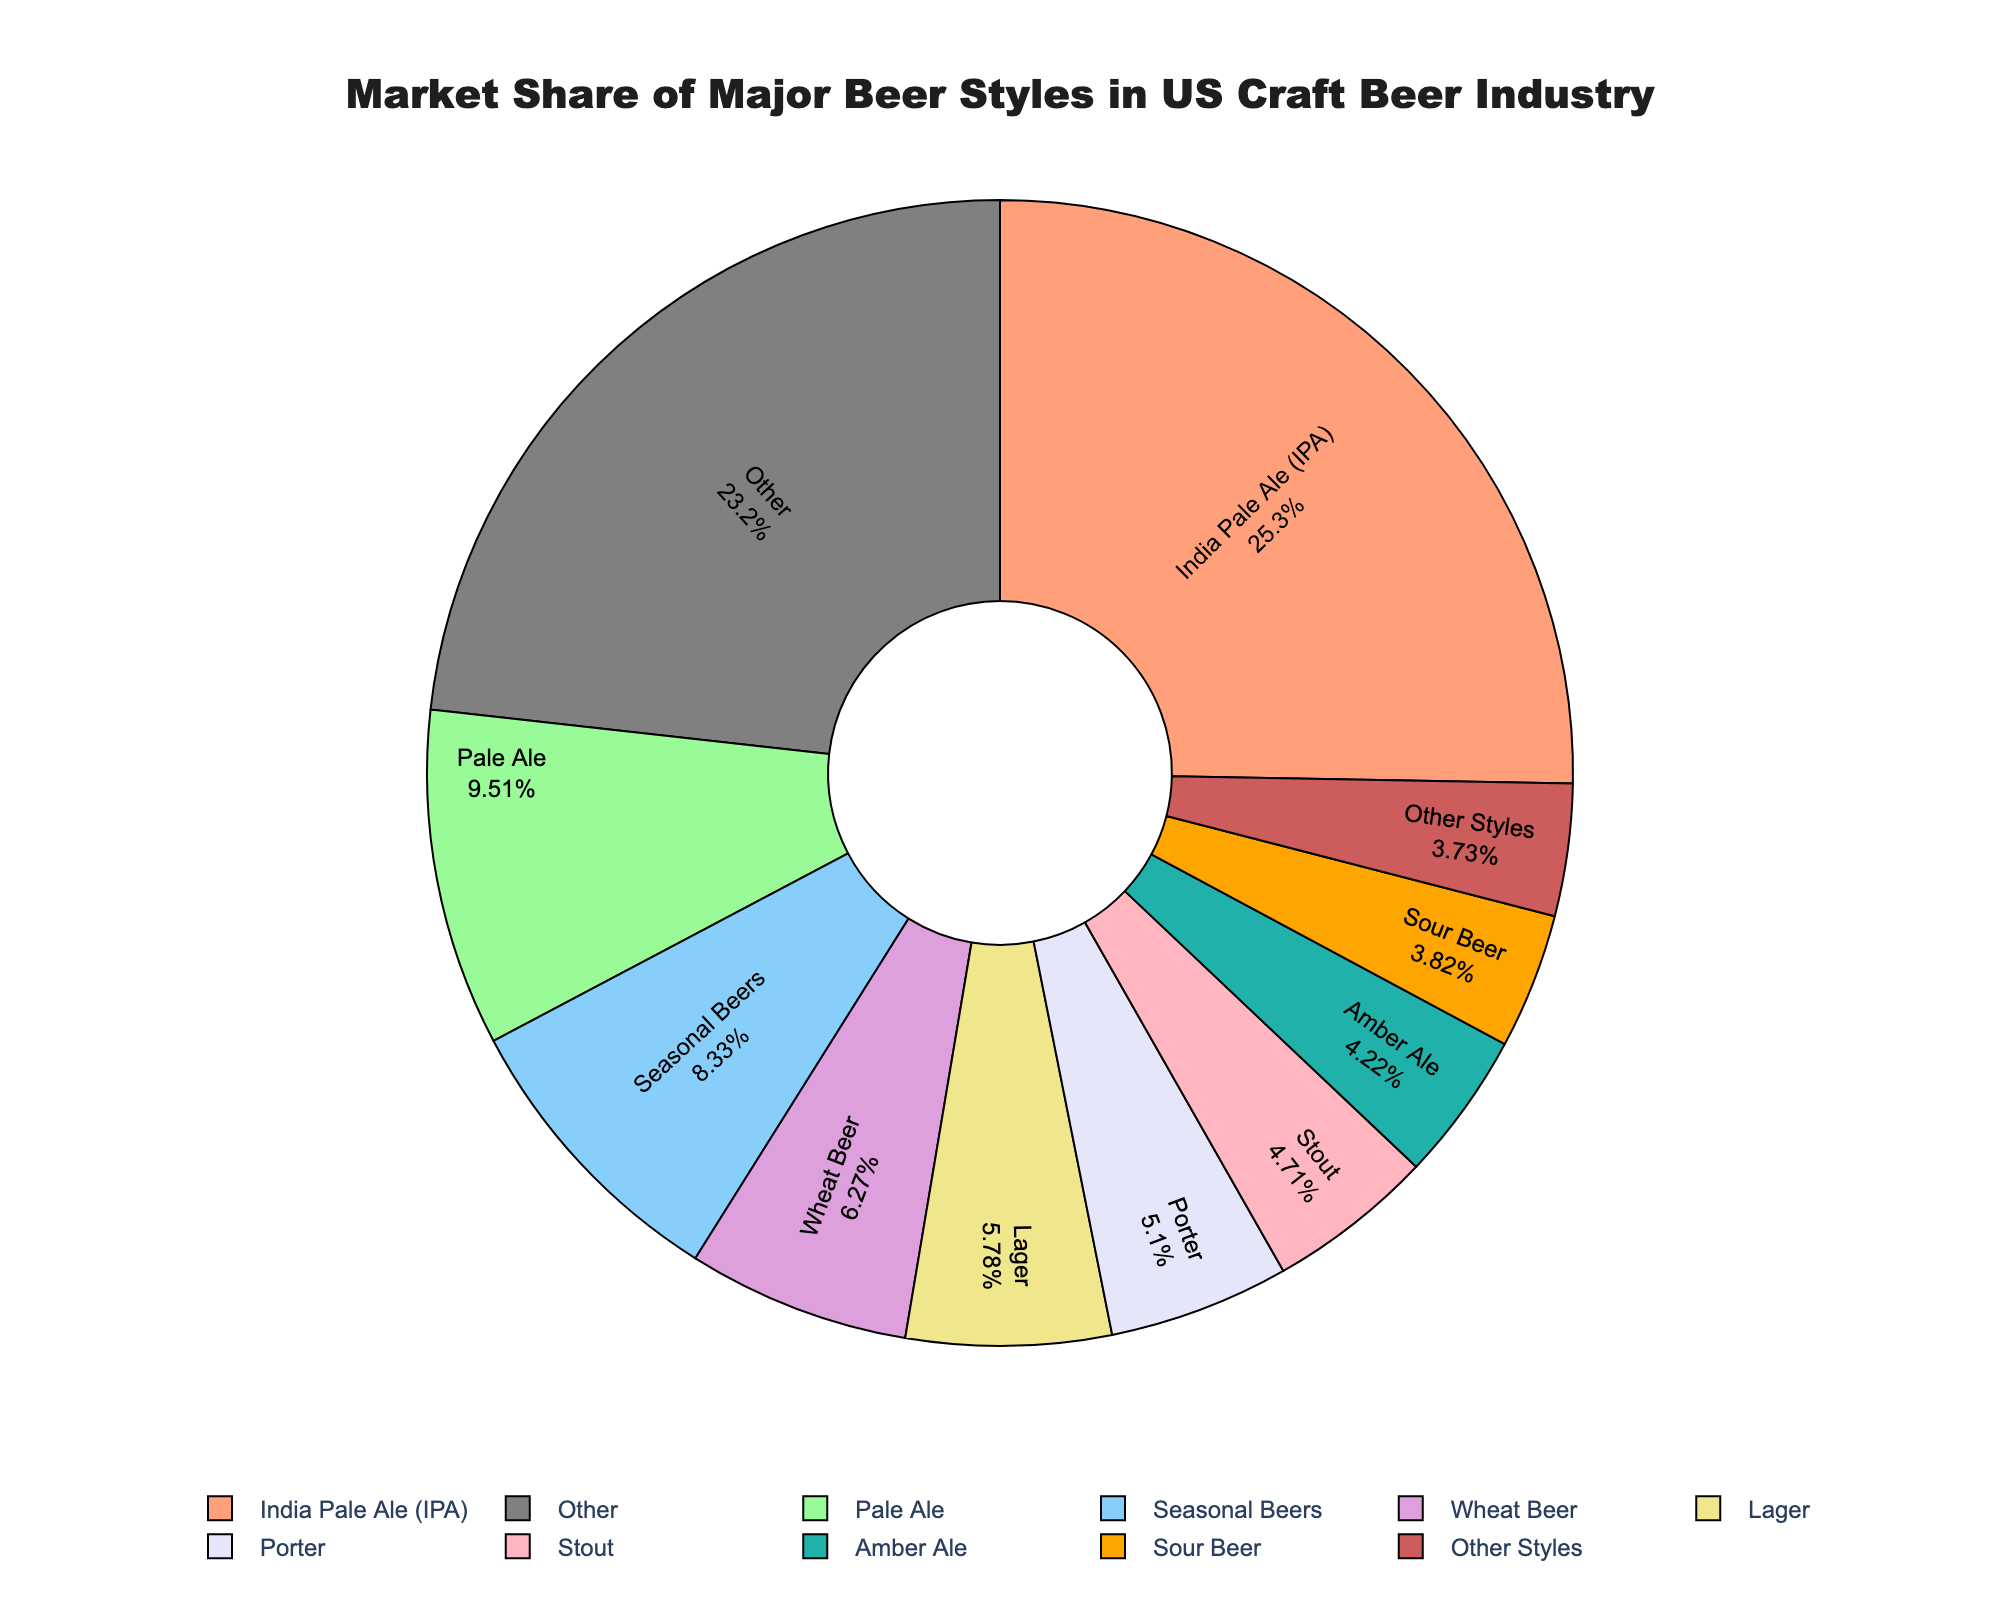What is the market share of IPAs compared to Stouts? The market share of IPAs is 25.8%, and the market share of Stouts is 4.8%. IPAs have a higher market share compared to Stouts.
Answer: IPAs have a higher market share What is the combined market share of Pale Ale and Seasonal Beers? The market share of Pale Ale is 9.7% and Seasonal Beers is 8.5%. Combined market share: 9.7 + 8.5 = 18.2%.
Answer: 18.2% Which beer style has a higher market share, Lager or Wheat Beer? The market share of Lager is 5.9%, and the market share of Wheat Beer is 6.4%. Wheat Beer has a higher market share than Lager.
Answer: Wheat Beer What is the difference in market share between the top beer style (IPA) and the lowest style among the top 10 (Sour Beer)? The market share of IPA is 25.8%. The market share of Sour Beer is 3.9%. The difference is 25.8 - 3.9 = 21.9%.
Answer: 21.9% Which beer style has the smallest market share within the top 10 beer styles? By examining the pie chart, Sour Beer has the smallest market share within the top 10 beer styles at 3.9%.
Answer: Sour Beer What percentage of the market share is held by Amber Ale and Brown Ale combined? The market share of Amber Ale is 4.3% and Brown Ale is 3.6%. Combined market share: 4.3 + 3.6 = 7.9%.
Answer: 7.9% What is the market share of the "Other" category? From the pie chart, the "Other" category includes all styles not in the top 10, which sums to 3.8%.
Answer: 3.8% Identify the beer style with the third highest market share. From the pie chart, after IPA (25.8%) and Pale Ale (9.7%), the third highest market share is held by Seasonal Beers at 8.5%.
Answer: Seasonal Beers How much more market share does IPA have than Porter? IPA has a market share of 25.8%, and Porter has 5.2%. Difference: 25.8 - 5.2 = 20.6%.
Answer: 20.6% Is the combined market share of Pilsner and Saison greater than that of Hefeweizen? The market share of Pilsner is 3.2% and Saison is 2.8%. Combined: 3.2 + 2.8 = 6.0%. Hefeweizen has 1.5%. Yes, 6.0% is greater than 1.5%.
Answer: Yes 